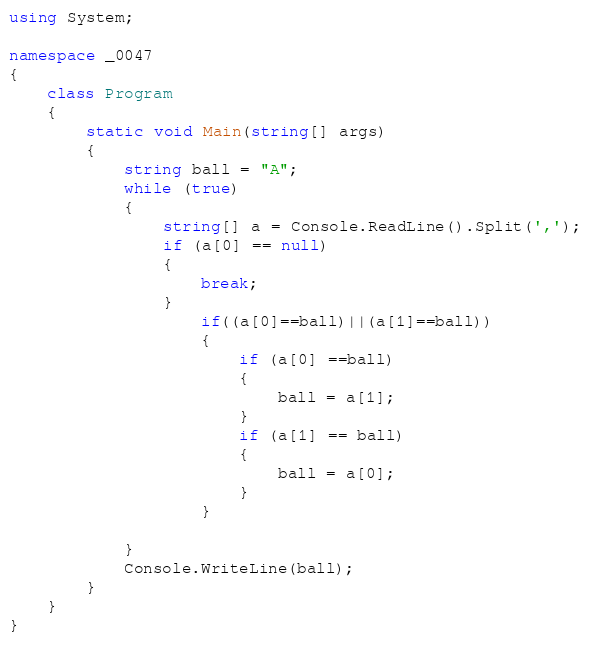<code> <loc_0><loc_0><loc_500><loc_500><_C#_>using System;

namespace _0047
{
    class Program
    {
        static void Main(string[] args)
        {
            string ball = "A";
            while (true)
            {
                string[] a = Console.ReadLine().Split(',');
                if (a[0] == null)
                {
                    break;
                }
                    if((a[0]==ball)||(a[1]==ball))
                    {
                        if (a[0] ==ball)
                        {
                            ball = a[1];
                        }
                        if (a[1] == ball)
                        {
                            ball = a[0];
                        }
                    }
                
            }
            Console.WriteLine(ball);
        }
    }
}</code> 